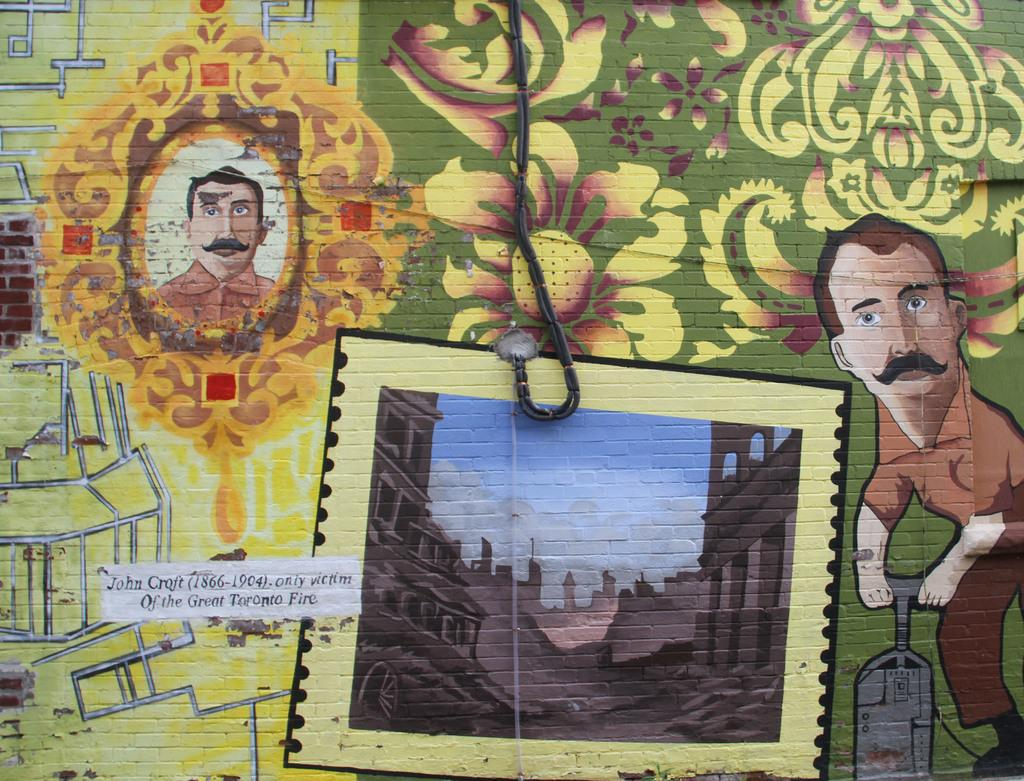What is present on the wall in the image? There is a painting on the wall in the image. Can you describe any other features of the wall? There is a rope hanging in the image. What type of car can be seen in the painting on the wall? There is no car present in the painting or the image. Is there a kettle visible in the image? No, there is no kettle present in the image. 